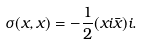Convert formula to latex. <formula><loc_0><loc_0><loc_500><loc_500>\sigma ( x , x ) = - \frac { 1 } { 2 } ( x i \bar { x } ) i .</formula> 